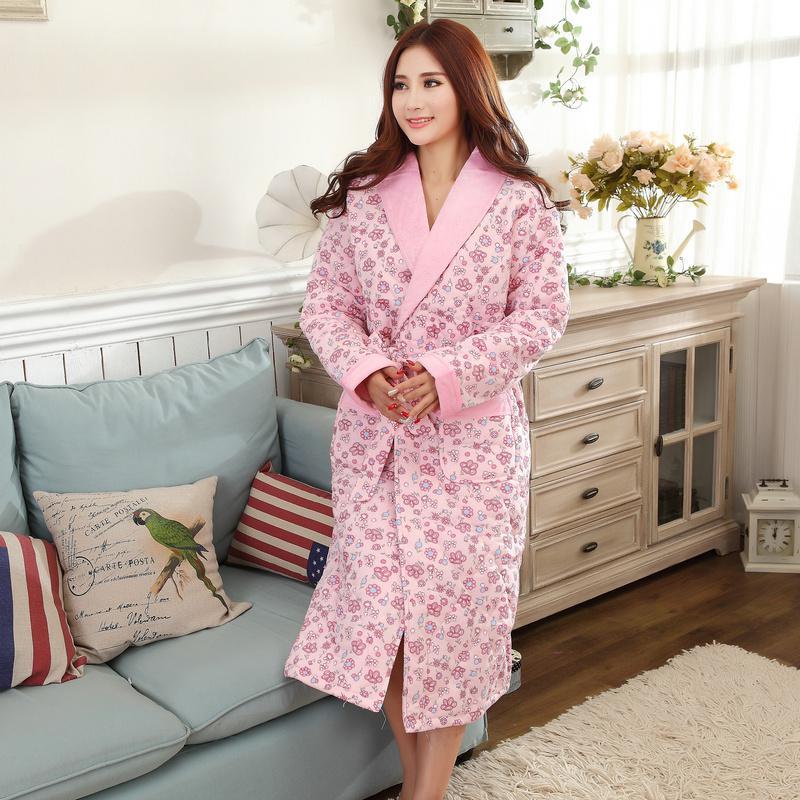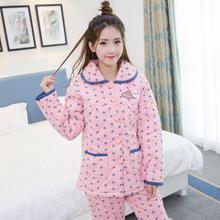The first image is the image on the left, the second image is the image on the right. Analyze the images presented: Is the assertion "There is a lamp behind a girl wearing pajamas." valid? Answer yes or no. No. The first image is the image on the left, the second image is the image on the right. For the images shown, is this caption "A model wears a pajama shorts set patterned all over with cute animals." true? Answer yes or no. No. 